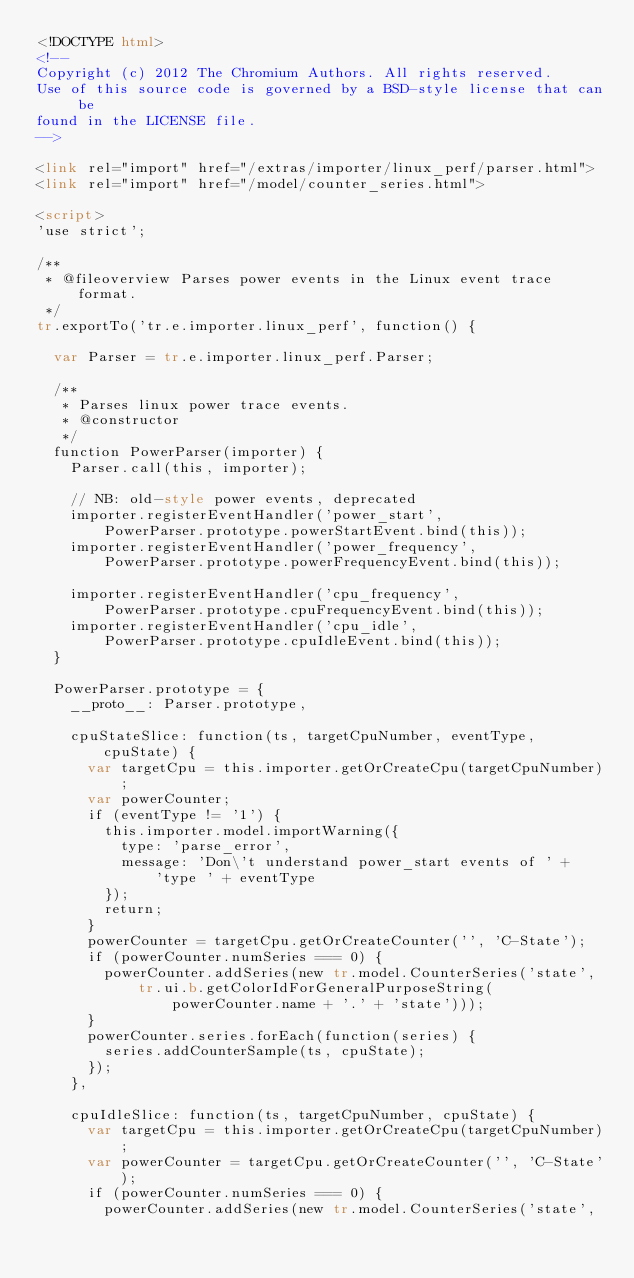Convert code to text. <code><loc_0><loc_0><loc_500><loc_500><_HTML_><!DOCTYPE html>
<!--
Copyright (c) 2012 The Chromium Authors. All rights reserved.
Use of this source code is governed by a BSD-style license that can be
found in the LICENSE file.
-->

<link rel="import" href="/extras/importer/linux_perf/parser.html">
<link rel="import" href="/model/counter_series.html">

<script>
'use strict';

/**
 * @fileoverview Parses power events in the Linux event trace format.
 */
tr.exportTo('tr.e.importer.linux_perf', function() {

  var Parser = tr.e.importer.linux_perf.Parser;

  /**
   * Parses linux power trace events.
   * @constructor
   */
  function PowerParser(importer) {
    Parser.call(this, importer);

    // NB: old-style power events, deprecated
    importer.registerEventHandler('power_start',
        PowerParser.prototype.powerStartEvent.bind(this));
    importer.registerEventHandler('power_frequency',
        PowerParser.prototype.powerFrequencyEvent.bind(this));

    importer.registerEventHandler('cpu_frequency',
        PowerParser.prototype.cpuFrequencyEvent.bind(this));
    importer.registerEventHandler('cpu_idle',
        PowerParser.prototype.cpuIdleEvent.bind(this));
  }

  PowerParser.prototype = {
    __proto__: Parser.prototype,

    cpuStateSlice: function(ts, targetCpuNumber, eventType, cpuState) {
      var targetCpu = this.importer.getOrCreateCpu(targetCpuNumber);
      var powerCounter;
      if (eventType != '1') {
        this.importer.model.importWarning({
          type: 'parse_error',
          message: 'Don\'t understand power_start events of ' +
              'type ' + eventType
        });
        return;
      }
      powerCounter = targetCpu.getOrCreateCounter('', 'C-State');
      if (powerCounter.numSeries === 0) {
        powerCounter.addSeries(new tr.model.CounterSeries('state',
            tr.ui.b.getColorIdForGeneralPurposeString(
                powerCounter.name + '.' + 'state')));
      }
      powerCounter.series.forEach(function(series) {
        series.addCounterSample(ts, cpuState);
      });
    },

    cpuIdleSlice: function(ts, targetCpuNumber, cpuState) {
      var targetCpu = this.importer.getOrCreateCpu(targetCpuNumber);
      var powerCounter = targetCpu.getOrCreateCounter('', 'C-State');
      if (powerCounter.numSeries === 0) {
        powerCounter.addSeries(new tr.model.CounterSeries('state',</code> 